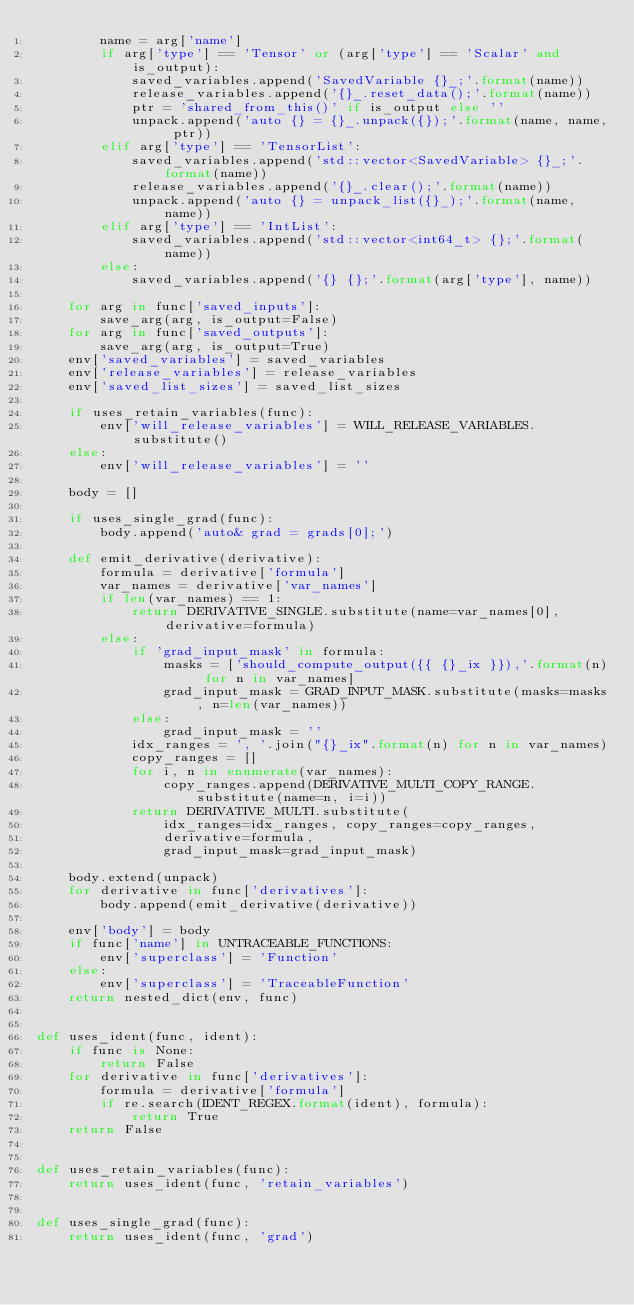<code> <loc_0><loc_0><loc_500><loc_500><_Python_>        name = arg['name']
        if arg['type'] == 'Tensor' or (arg['type'] == 'Scalar' and is_output):
            saved_variables.append('SavedVariable {}_;'.format(name))
            release_variables.append('{}_.reset_data();'.format(name))
            ptr = 'shared_from_this()' if is_output else ''
            unpack.append('auto {} = {}_.unpack({});'.format(name, name, ptr))
        elif arg['type'] == 'TensorList':
            saved_variables.append('std::vector<SavedVariable> {}_;'.format(name))
            release_variables.append('{}_.clear();'.format(name))
            unpack.append('auto {} = unpack_list({}_);'.format(name, name))
        elif arg['type'] == 'IntList':
            saved_variables.append('std::vector<int64_t> {};'.format(name))
        else:
            saved_variables.append('{} {};'.format(arg['type'], name))

    for arg in func['saved_inputs']:
        save_arg(arg, is_output=False)
    for arg in func['saved_outputs']:
        save_arg(arg, is_output=True)
    env['saved_variables'] = saved_variables
    env['release_variables'] = release_variables
    env['saved_list_sizes'] = saved_list_sizes

    if uses_retain_variables(func):
        env['will_release_variables'] = WILL_RELEASE_VARIABLES.substitute()
    else:
        env['will_release_variables'] = ''

    body = []

    if uses_single_grad(func):
        body.append('auto& grad = grads[0];')

    def emit_derivative(derivative):
        formula = derivative['formula']
        var_names = derivative['var_names']
        if len(var_names) == 1:
            return DERIVATIVE_SINGLE.substitute(name=var_names[0], derivative=formula)
        else:
            if 'grad_input_mask' in formula:
                masks = ['should_compute_output({{ {}_ix }}),'.format(n) for n in var_names]
                grad_input_mask = GRAD_INPUT_MASK.substitute(masks=masks, n=len(var_names))
            else:
                grad_input_mask = ''
            idx_ranges = ', '.join("{}_ix".format(n) for n in var_names)
            copy_ranges = []
            for i, n in enumerate(var_names):
                copy_ranges.append(DERIVATIVE_MULTI_COPY_RANGE.substitute(name=n, i=i))
            return DERIVATIVE_MULTI.substitute(
                idx_ranges=idx_ranges, copy_ranges=copy_ranges,
                derivative=formula,
                grad_input_mask=grad_input_mask)

    body.extend(unpack)
    for derivative in func['derivatives']:
        body.append(emit_derivative(derivative))

    env['body'] = body
    if func['name'] in UNTRACEABLE_FUNCTIONS:
        env['superclass'] = 'Function'
    else:
        env['superclass'] = 'TraceableFunction'
    return nested_dict(env, func)


def uses_ident(func, ident):
    if func is None:
        return False
    for derivative in func['derivatives']:
        formula = derivative['formula']
        if re.search(IDENT_REGEX.format(ident), formula):
            return True
    return False


def uses_retain_variables(func):
    return uses_ident(func, 'retain_variables')


def uses_single_grad(func):
    return uses_ident(func, 'grad')
</code> 